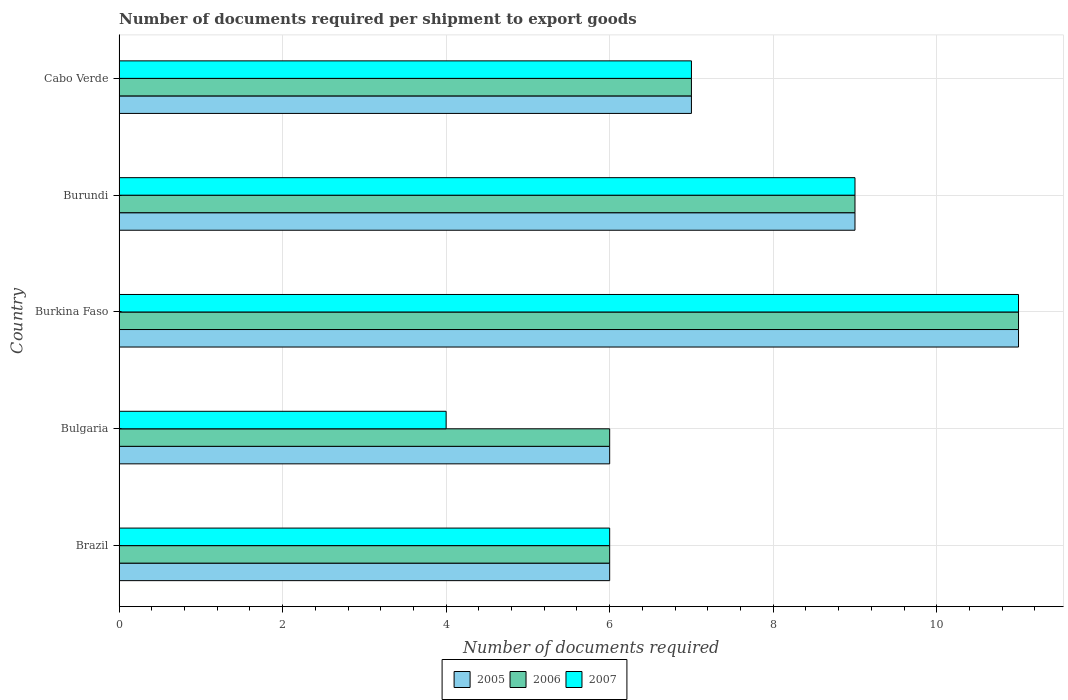How many groups of bars are there?
Your answer should be compact. 5. Are the number of bars per tick equal to the number of legend labels?
Give a very brief answer. Yes. Are the number of bars on each tick of the Y-axis equal?
Your answer should be compact. Yes. How many bars are there on the 3rd tick from the top?
Ensure brevity in your answer.  3. What is the label of the 3rd group of bars from the top?
Provide a succinct answer. Burkina Faso. Across all countries, what is the minimum number of documents required per shipment to export goods in 2006?
Ensure brevity in your answer.  6. In which country was the number of documents required per shipment to export goods in 2007 maximum?
Offer a very short reply. Burkina Faso. What is the total number of documents required per shipment to export goods in 2006 in the graph?
Provide a succinct answer. 39. What is the difference between the number of documents required per shipment to export goods in 2007 in Burkina Faso and the number of documents required per shipment to export goods in 2005 in Bulgaria?
Ensure brevity in your answer.  5. What is the average number of documents required per shipment to export goods in 2007 per country?
Your answer should be very brief. 7.4. In how many countries, is the number of documents required per shipment to export goods in 2005 greater than 3.6 ?
Ensure brevity in your answer.  5. What is the ratio of the number of documents required per shipment to export goods in 2007 in Burundi to that in Cabo Verde?
Give a very brief answer. 1.29. Is the number of documents required per shipment to export goods in 2005 in Brazil less than that in Bulgaria?
Your answer should be compact. No. What is the difference between the highest and the second highest number of documents required per shipment to export goods in 2006?
Provide a succinct answer. 2. What is the difference between the highest and the lowest number of documents required per shipment to export goods in 2007?
Your response must be concise. 7. Is the sum of the number of documents required per shipment to export goods in 2005 in Burundi and Cabo Verde greater than the maximum number of documents required per shipment to export goods in 2007 across all countries?
Provide a short and direct response. Yes. What does the 1st bar from the top in Burkina Faso represents?
Make the answer very short. 2007. Is it the case that in every country, the sum of the number of documents required per shipment to export goods in 2005 and number of documents required per shipment to export goods in 2007 is greater than the number of documents required per shipment to export goods in 2006?
Give a very brief answer. Yes. How many bars are there?
Give a very brief answer. 15. How many countries are there in the graph?
Provide a succinct answer. 5. Does the graph contain any zero values?
Make the answer very short. No. How are the legend labels stacked?
Your response must be concise. Horizontal. What is the title of the graph?
Make the answer very short. Number of documents required per shipment to export goods. What is the label or title of the X-axis?
Your response must be concise. Number of documents required. What is the Number of documents required in 2005 in Brazil?
Keep it short and to the point. 6. What is the Number of documents required of 2006 in Brazil?
Offer a terse response. 6. What is the Number of documents required in 2007 in Brazil?
Keep it short and to the point. 6. What is the Number of documents required in 2005 in Bulgaria?
Offer a very short reply. 6. What is the Number of documents required in 2006 in Burkina Faso?
Offer a terse response. 11. What is the Number of documents required of 2006 in Burundi?
Offer a terse response. 9. What is the Number of documents required of 2005 in Cabo Verde?
Keep it short and to the point. 7. What is the Number of documents required in 2007 in Cabo Verde?
Your answer should be compact. 7. Across all countries, what is the minimum Number of documents required in 2005?
Keep it short and to the point. 6. Across all countries, what is the minimum Number of documents required of 2006?
Keep it short and to the point. 6. Across all countries, what is the minimum Number of documents required in 2007?
Your response must be concise. 4. What is the total Number of documents required in 2005 in the graph?
Your answer should be compact. 39. What is the difference between the Number of documents required in 2005 in Brazil and that in Bulgaria?
Your response must be concise. 0. What is the difference between the Number of documents required in 2006 in Brazil and that in Bulgaria?
Provide a short and direct response. 0. What is the difference between the Number of documents required in 2007 in Brazil and that in Bulgaria?
Make the answer very short. 2. What is the difference between the Number of documents required of 2006 in Brazil and that in Burkina Faso?
Your response must be concise. -5. What is the difference between the Number of documents required in 2007 in Brazil and that in Burkina Faso?
Provide a short and direct response. -5. What is the difference between the Number of documents required of 2005 in Brazil and that in Cabo Verde?
Ensure brevity in your answer.  -1. What is the difference between the Number of documents required in 2006 in Brazil and that in Cabo Verde?
Ensure brevity in your answer.  -1. What is the difference between the Number of documents required in 2007 in Brazil and that in Cabo Verde?
Provide a short and direct response. -1. What is the difference between the Number of documents required in 2005 in Bulgaria and that in Burkina Faso?
Your answer should be very brief. -5. What is the difference between the Number of documents required of 2006 in Bulgaria and that in Burkina Faso?
Your answer should be compact. -5. What is the difference between the Number of documents required of 2007 in Bulgaria and that in Burkina Faso?
Ensure brevity in your answer.  -7. What is the difference between the Number of documents required of 2005 in Bulgaria and that in Burundi?
Offer a very short reply. -3. What is the difference between the Number of documents required in 2006 in Bulgaria and that in Burundi?
Give a very brief answer. -3. What is the difference between the Number of documents required in 2007 in Bulgaria and that in Burundi?
Offer a very short reply. -5. What is the difference between the Number of documents required in 2007 in Burundi and that in Cabo Verde?
Your answer should be very brief. 2. What is the difference between the Number of documents required of 2005 in Brazil and the Number of documents required of 2007 in Bulgaria?
Ensure brevity in your answer.  2. What is the difference between the Number of documents required in 2005 in Brazil and the Number of documents required in 2006 in Burundi?
Ensure brevity in your answer.  -3. What is the difference between the Number of documents required in 2005 in Brazil and the Number of documents required in 2007 in Burundi?
Provide a short and direct response. -3. What is the difference between the Number of documents required in 2005 in Brazil and the Number of documents required in 2007 in Cabo Verde?
Give a very brief answer. -1. What is the difference between the Number of documents required in 2006 in Brazil and the Number of documents required in 2007 in Cabo Verde?
Offer a very short reply. -1. What is the difference between the Number of documents required in 2005 in Bulgaria and the Number of documents required in 2006 in Burkina Faso?
Offer a terse response. -5. What is the difference between the Number of documents required in 2005 in Bulgaria and the Number of documents required in 2007 in Burkina Faso?
Keep it short and to the point. -5. What is the difference between the Number of documents required of 2006 in Bulgaria and the Number of documents required of 2007 in Burkina Faso?
Ensure brevity in your answer.  -5. What is the difference between the Number of documents required in 2005 in Bulgaria and the Number of documents required in 2006 in Burundi?
Offer a terse response. -3. What is the difference between the Number of documents required in 2006 in Bulgaria and the Number of documents required in 2007 in Burundi?
Offer a terse response. -3. What is the difference between the Number of documents required of 2005 in Bulgaria and the Number of documents required of 2006 in Cabo Verde?
Provide a short and direct response. -1. What is the difference between the Number of documents required of 2005 in Burkina Faso and the Number of documents required of 2006 in Burundi?
Your response must be concise. 2. What is the difference between the Number of documents required of 2006 in Burkina Faso and the Number of documents required of 2007 in Burundi?
Ensure brevity in your answer.  2. What is the difference between the Number of documents required in 2005 in Burkina Faso and the Number of documents required in 2006 in Cabo Verde?
Keep it short and to the point. 4. What is the difference between the Number of documents required in 2005 in Burkina Faso and the Number of documents required in 2007 in Cabo Verde?
Keep it short and to the point. 4. What is the difference between the Number of documents required of 2005 in Burundi and the Number of documents required of 2007 in Cabo Verde?
Offer a very short reply. 2. What is the difference between the Number of documents required of 2006 in Burundi and the Number of documents required of 2007 in Cabo Verde?
Offer a very short reply. 2. What is the average Number of documents required of 2007 per country?
Your response must be concise. 7.4. What is the difference between the Number of documents required in 2005 and Number of documents required in 2006 in Brazil?
Ensure brevity in your answer.  0. What is the difference between the Number of documents required in 2005 and Number of documents required in 2007 in Brazil?
Keep it short and to the point. 0. What is the difference between the Number of documents required in 2006 and Number of documents required in 2007 in Brazil?
Your answer should be very brief. 0. What is the difference between the Number of documents required in 2005 and Number of documents required in 2007 in Bulgaria?
Provide a short and direct response. 2. What is the difference between the Number of documents required of 2006 and Number of documents required of 2007 in Bulgaria?
Make the answer very short. 2. What is the difference between the Number of documents required in 2005 and Number of documents required in 2006 in Burkina Faso?
Your answer should be compact. 0. What is the difference between the Number of documents required in 2005 and Number of documents required in 2007 in Burkina Faso?
Provide a succinct answer. 0. What is the difference between the Number of documents required of 2006 and Number of documents required of 2007 in Burkina Faso?
Offer a very short reply. 0. What is the difference between the Number of documents required in 2005 and Number of documents required in 2006 in Burundi?
Your answer should be very brief. 0. What is the difference between the Number of documents required in 2006 and Number of documents required in 2007 in Burundi?
Give a very brief answer. 0. What is the difference between the Number of documents required of 2005 and Number of documents required of 2006 in Cabo Verde?
Provide a short and direct response. 0. What is the ratio of the Number of documents required in 2006 in Brazil to that in Bulgaria?
Offer a very short reply. 1. What is the ratio of the Number of documents required in 2007 in Brazil to that in Bulgaria?
Your answer should be very brief. 1.5. What is the ratio of the Number of documents required in 2005 in Brazil to that in Burkina Faso?
Provide a short and direct response. 0.55. What is the ratio of the Number of documents required in 2006 in Brazil to that in Burkina Faso?
Offer a very short reply. 0.55. What is the ratio of the Number of documents required of 2007 in Brazil to that in Burkina Faso?
Ensure brevity in your answer.  0.55. What is the ratio of the Number of documents required of 2006 in Brazil to that in Burundi?
Provide a succinct answer. 0.67. What is the ratio of the Number of documents required of 2007 in Brazil to that in Burundi?
Provide a short and direct response. 0.67. What is the ratio of the Number of documents required in 2006 in Brazil to that in Cabo Verde?
Ensure brevity in your answer.  0.86. What is the ratio of the Number of documents required in 2007 in Brazil to that in Cabo Verde?
Give a very brief answer. 0.86. What is the ratio of the Number of documents required of 2005 in Bulgaria to that in Burkina Faso?
Your answer should be compact. 0.55. What is the ratio of the Number of documents required of 2006 in Bulgaria to that in Burkina Faso?
Keep it short and to the point. 0.55. What is the ratio of the Number of documents required of 2007 in Bulgaria to that in Burkina Faso?
Offer a very short reply. 0.36. What is the ratio of the Number of documents required of 2005 in Bulgaria to that in Burundi?
Your response must be concise. 0.67. What is the ratio of the Number of documents required of 2006 in Bulgaria to that in Burundi?
Provide a succinct answer. 0.67. What is the ratio of the Number of documents required in 2007 in Bulgaria to that in Burundi?
Your response must be concise. 0.44. What is the ratio of the Number of documents required in 2005 in Bulgaria to that in Cabo Verde?
Provide a succinct answer. 0.86. What is the ratio of the Number of documents required in 2005 in Burkina Faso to that in Burundi?
Offer a terse response. 1.22. What is the ratio of the Number of documents required in 2006 in Burkina Faso to that in Burundi?
Your response must be concise. 1.22. What is the ratio of the Number of documents required of 2007 in Burkina Faso to that in Burundi?
Your answer should be compact. 1.22. What is the ratio of the Number of documents required in 2005 in Burkina Faso to that in Cabo Verde?
Make the answer very short. 1.57. What is the ratio of the Number of documents required in 2006 in Burkina Faso to that in Cabo Verde?
Ensure brevity in your answer.  1.57. What is the ratio of the Number of documents required of 2007 in Burkina Faso to that in Cabo Verde?
Make the answer very short. 1.57. What is the ratio of the Number of documents required of 2005 in Burundi to that in Cabo Verde?
Make the answer very short. 1.29. What is the ratio of the Number of documents required of 2006 in Burundi to that in Cabo Verde?
Your answer should be compact. 1.29. What is the difference between the highest and the second highest Number of documents required of 2005?
Offer a very short reply. 2. What is the difference between the highest and the second highest Number of documents required in 2006?
Your answer should be very brief. 2. What is the difference between the highest and the lowest Number of documents required of 2005?
Give a very brief answer. 5. What is the difference between the highest and the lowest Number of documents required in 2006?
Your answer should be compact. 5. What is the difference between the highest and the lowest Number of documents required of 2007?
Give a very brief answer. 7. 